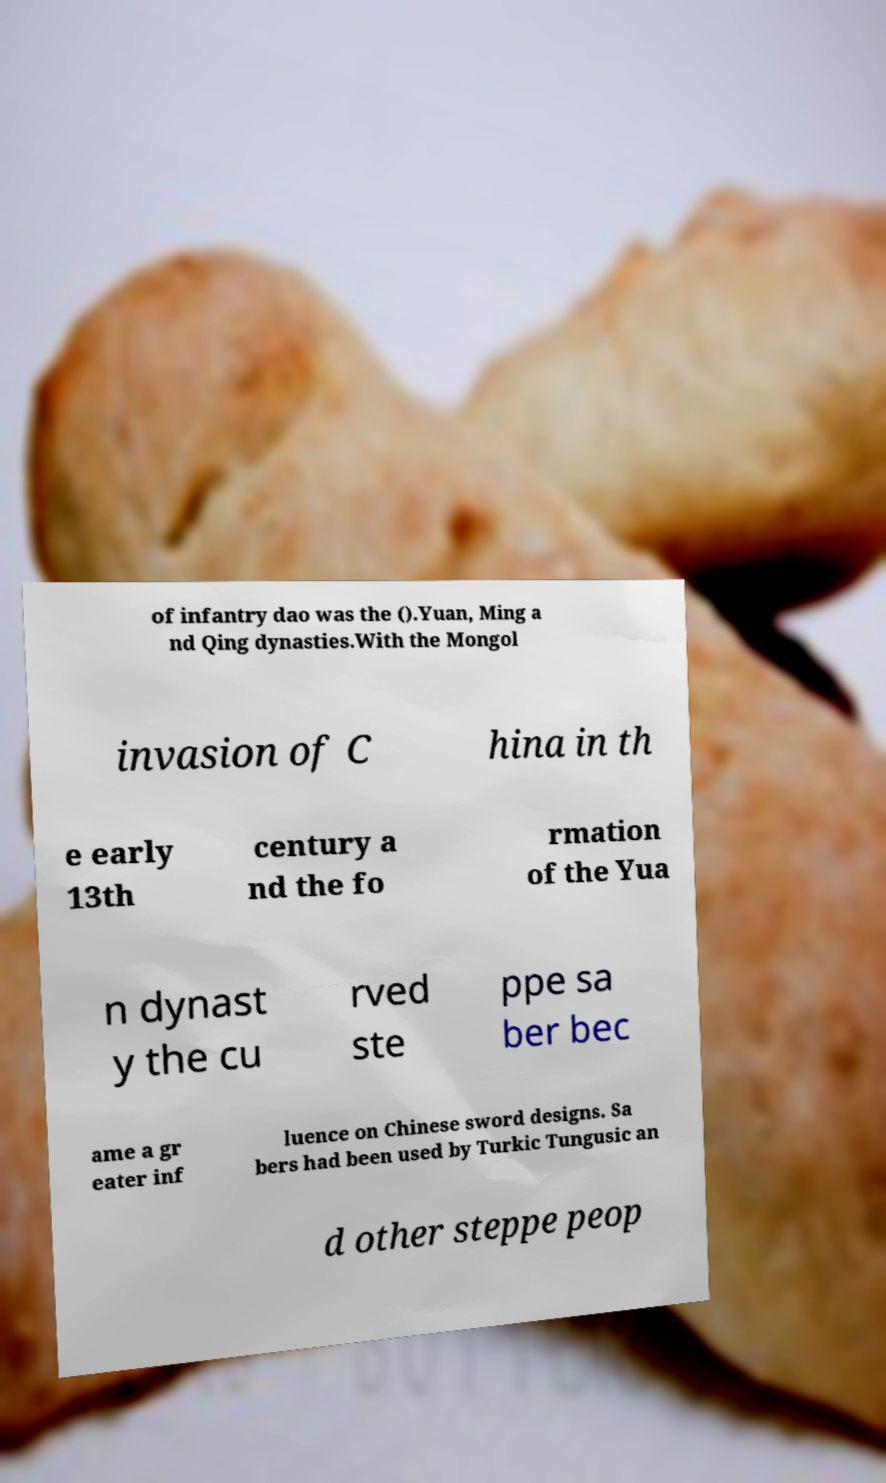Please read and relay the text visible in this image. What does it say? of infantry dao was the ().Yuan, Ming a nd Qing dynasties.With the Mongol invasion of C hina in th e early 13th century a nd the fo rmation of the Yua n dynast y the cu rved ste ppe sa ber bec ame a gr eater inf luence on Chinese sword designs. Sa bers had been used by Turkic Tungusic an d other steppe peop 